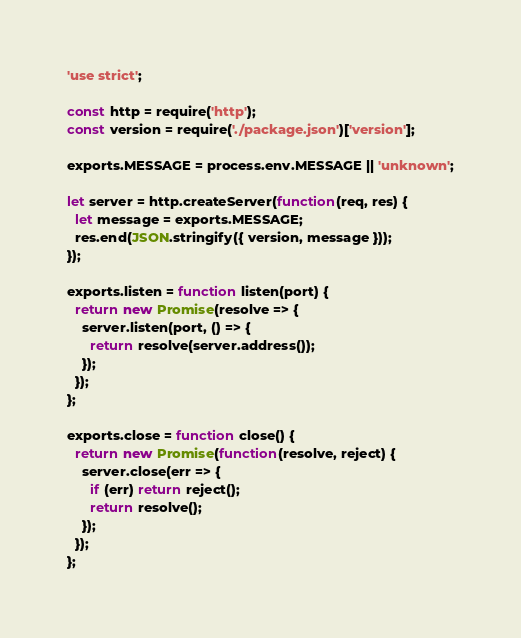<code> <loc_0><loc_0><loc_500><loc_500><_JavaScript_>'use strict';

const http = require('http');
const version = require('./package.json')['version'];

exports.MESSAGE = process.env.MESSAGE || 'unknown';

let server = http.createServer(function(req, res) {
  let message = exports.MESSAGE;
  res.end(JSON.stringify({ version, message }));
});

exports.listen = function listen(port) {
  return new Promise(resolve => {
    server.listen(port, () => {
      return resolve(server.address());
    });
  });
};

exports.close = function close() {
  return new Promise(function(resolve, reject) {
    server.close(err => {
      if (err) return reject();
      return resolve();
    });
  });
};
</code> 